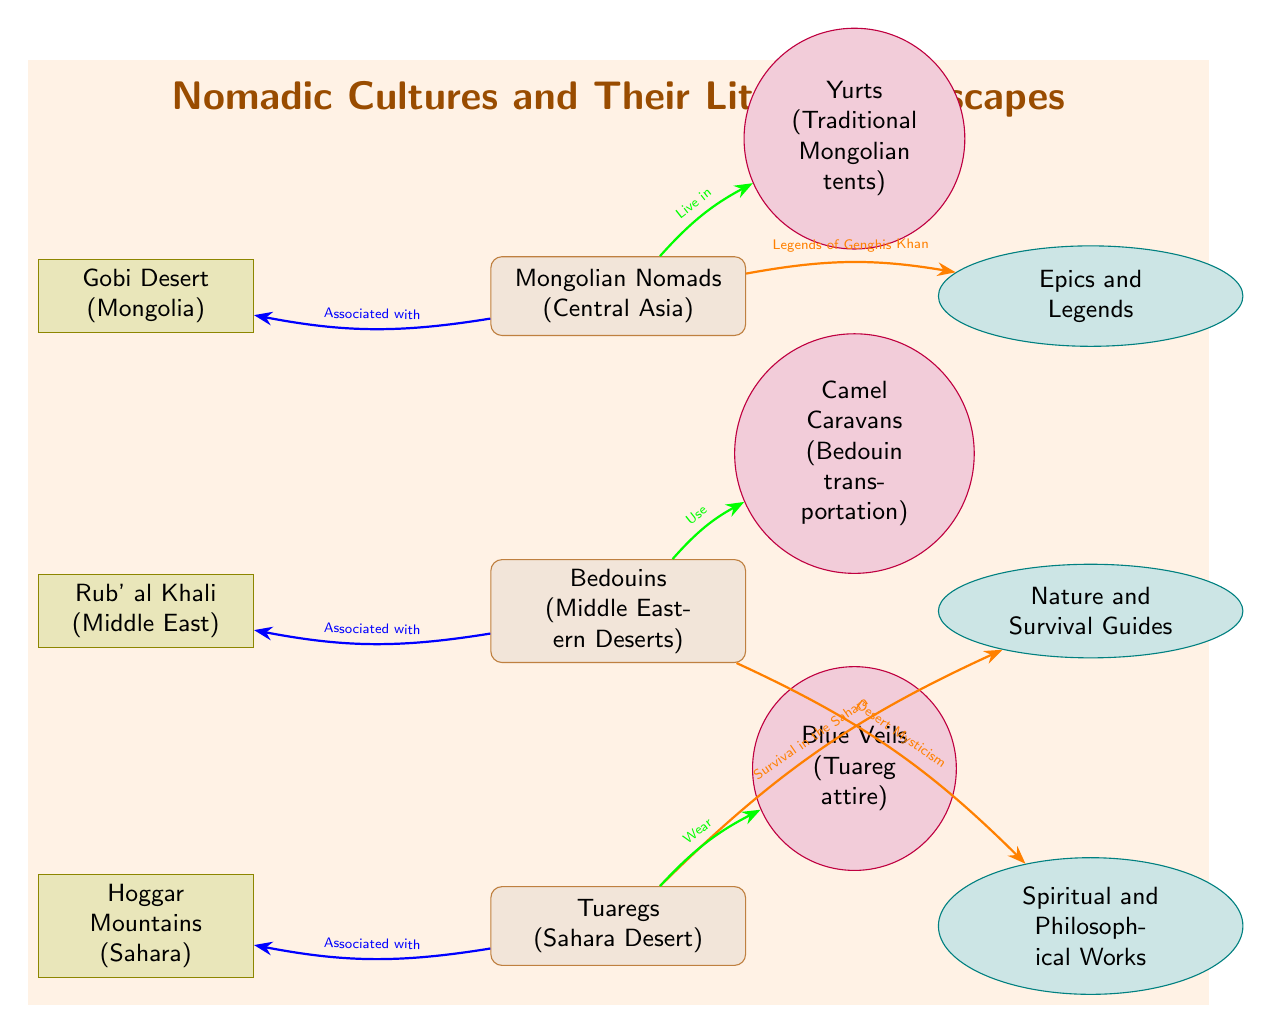What are the three nomadic cultures represented in the diagram? The three nomadic cultures listed in the diagram are Mongolian Nomads, Bedouins, and Tuaregs. These cultures are depicted as nodes on the left side of the diagram.
Answer: Mongolian Nomads, Bedouins, Tuaregs Which book genre is associated with Mongolian Nomads? The specific book genre associated with Mongolian Nomads in the diagram is "Epics and Legends" as shown in the connecting arrow.
Answer: Epics and Legends How many book genres are illustrated in the diagram? The diagram illustrates three book genres, each represented as an ellipse node. They are located on the right side of the diagram.
Answer: 3 What cultural illustration is connected to Bedouins? The cultural illustration connected to Bedouins is "Camel Caravans," which is depicted by the connection arrow leading from the Bedouin node to the illustration node.
Answer: Camel Caravans Which geographic feature is associated with the Tuareg culture? The geographic feature associated with the Tuareg culture is the "Hoggar Mountains," which is indicated by the connection arrow from the Tuareg node to the geographic feature node.
Answer: Hoggar Mountains What is the connection type between the Tuareg and their book genre? The connection type is labeled "Survival in the Sahara," showing a reason for the association between Tuareg and the book genre "Nature and Survival Guides."
Answer: Survival in the Sahara Which nomadic culture lives in the Gobi Desert? The nomadic culture that lives in the Gobi Desert is the "Mongolian Nomads," which is shown through the connecting arrow from the Mongolian Nomads to the geographic feature node.
Answer: Mongolian Nomads What color represents the arrows connecting nomadic cultures to their geographic features? The color of the arrows connecting nomadic cultures to their geographic features is blue, as indicated by the arrow style in the diagram.
Answer: Blue 